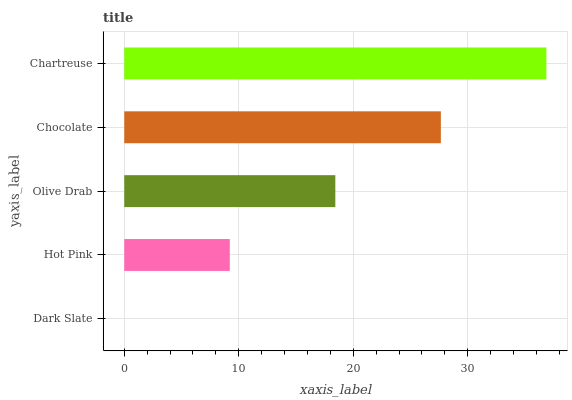Is Dark Slate the minimum?
Answer yes or no. Yes. Is Chartreuse the maximum?
Answer yes or no. Yes. Is Hot Pink the minimum?
Answer yes or no. No. Is Hot Pink the maximum?
Answer yes or no. No. Is Hot Pink greater than Dark Slate?
Answer yes or no. Yes. Is Dark Slate less than Hot Pink?
Answer yes or no. Yes. Is Dark Slate greater than Hot Pink?
Answer yes or no. No. Is Hot Pink less than Dark Slate?
Answer yes or no. No. Is Olive Drab the high median?
Answer yes or no. Yes. Is Olive Drab the low median?
Answer yes or no. Yes. Is Dark Slate the high median?
Answer yes or no. No. Is Dark Slate the low median?
Answer yes or no. No. 